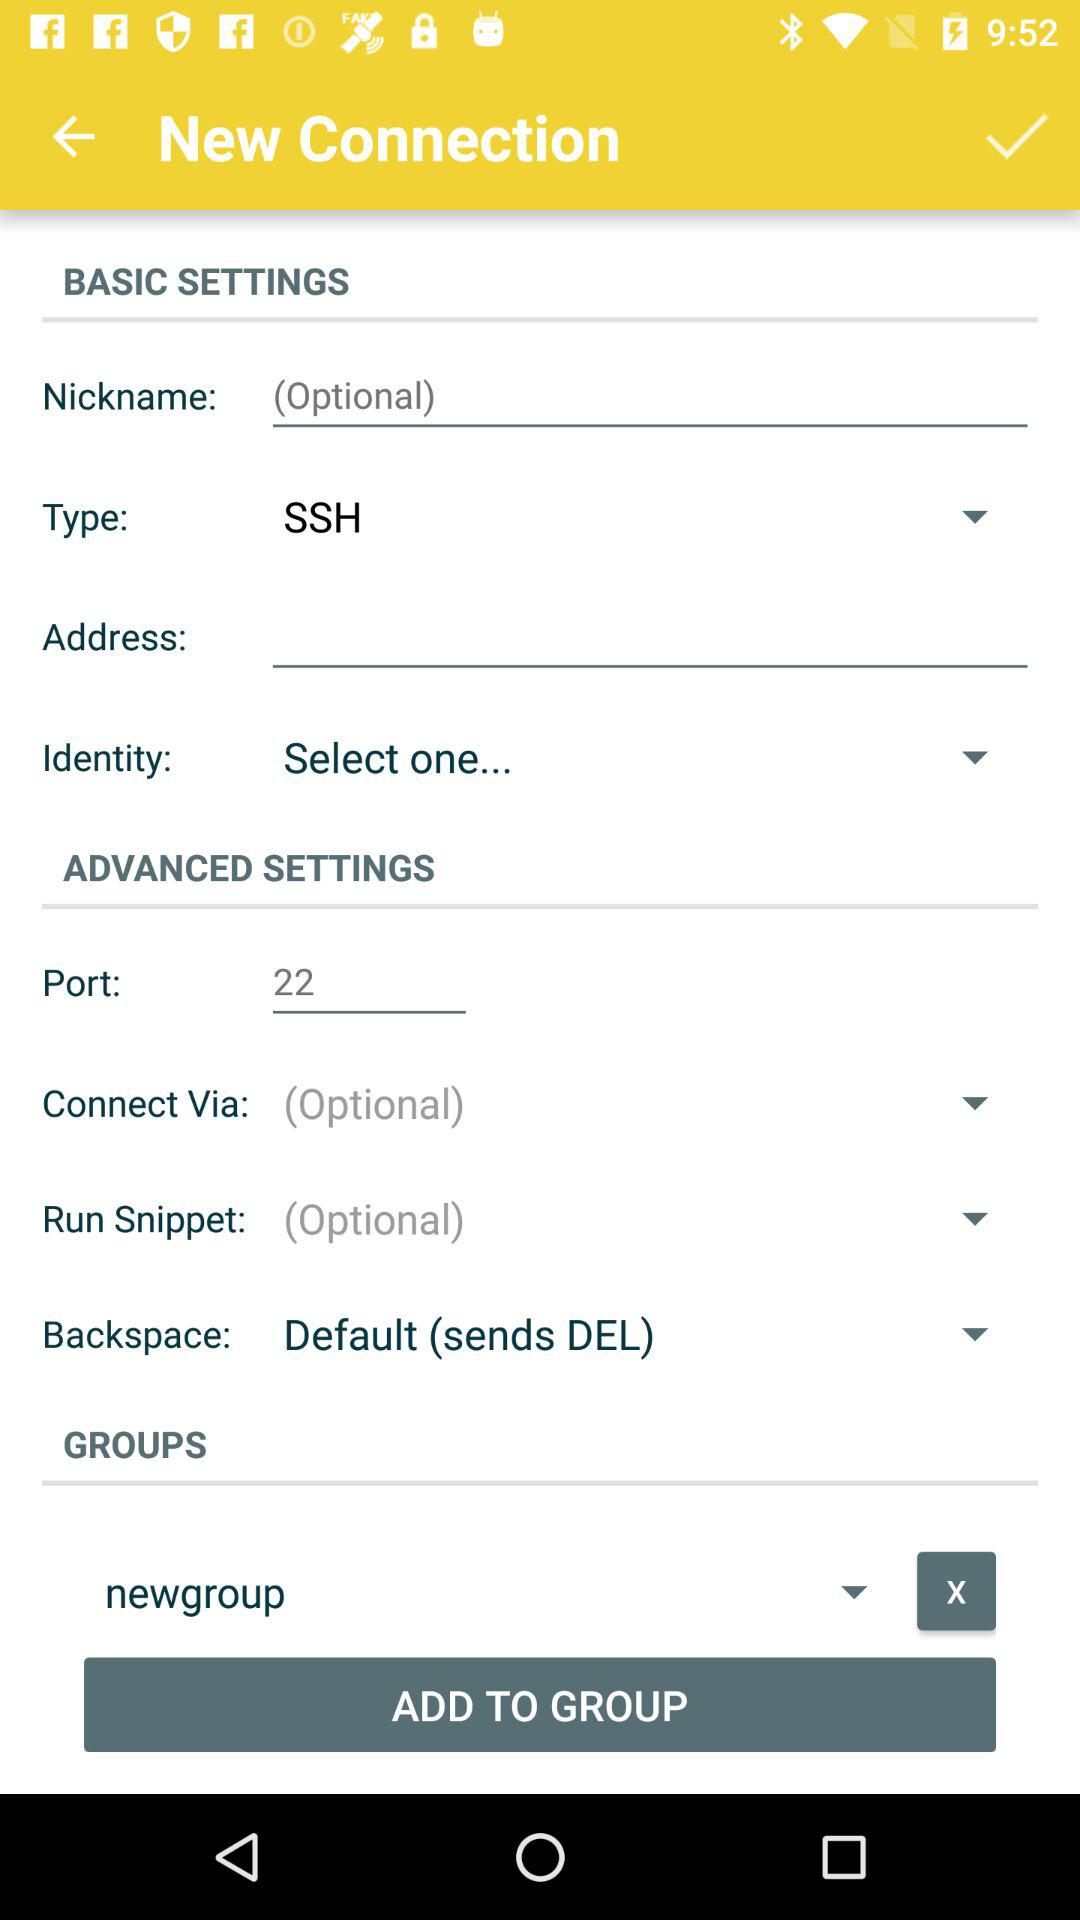What is the port number? The port number is 22. 